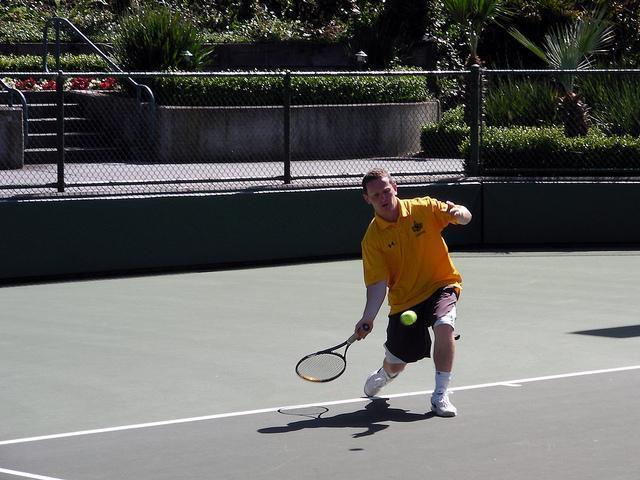What is the man attempting to do with the ball?
Choose the correct response and explain in the format: 'Answer: answer
Rationale: rationale.'
Options: Grab it, hit it, punch it, kick it. Answer: hit it.
Rationale: The man wants to hit. 